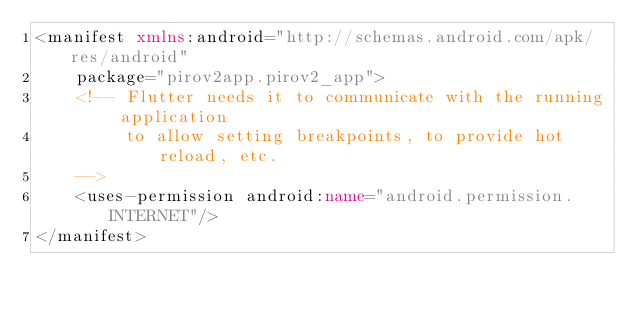<code> <loc_0><loc_0><loc_500><loc_500><_XML_><manifest xmlns:android="http://schemas.android.com/apk/res/android"
    package="pirov2app.pirov2_app">
    <!-- Flutter needs it to communicate with the running application
         to allow setting breakpoints, to provide hot reload, etc.
    -->
    <uses-permission android:name="android.permission.INTERNET"/>
</manifest>
</code> 